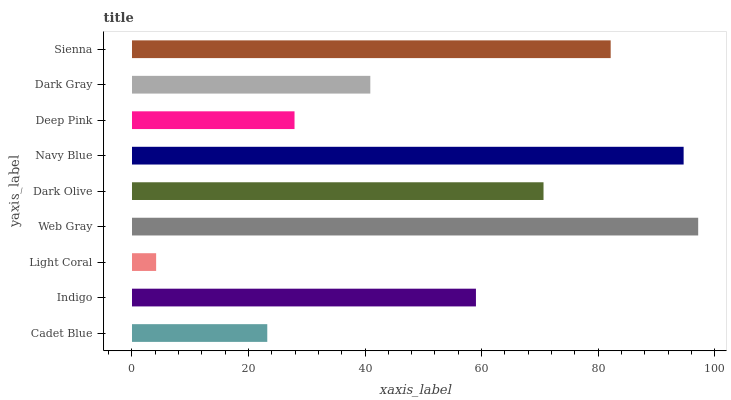Is Light Coral the minimum?
Answer yes or no. Yes. Is Web Gray the maximum?
Answer yes or no. Yes. Is Indigo the minimum?
Answer yes or no. No. Is Indigo the maximum?
Answer yes or no. No. Is Indigo greater than Cadet Blue?
Answer yes or no. Yes. Is Cadet Blue less than Indigo?
Answer yes or no. Yes. Is Cadet Blue greater than Indigo?
Answer yes or no. No. Is Indigo less than Cadet Blue?
Answer yes or no. No. Is Indigo the high median?
Answer yes or no. Yes. Is Indigo the low median?
Answer yes or no. Yes. Is Sienna the high median?
Answer yes or no. No. Is Dark Olive the low median?
Answer yes or no. No. 